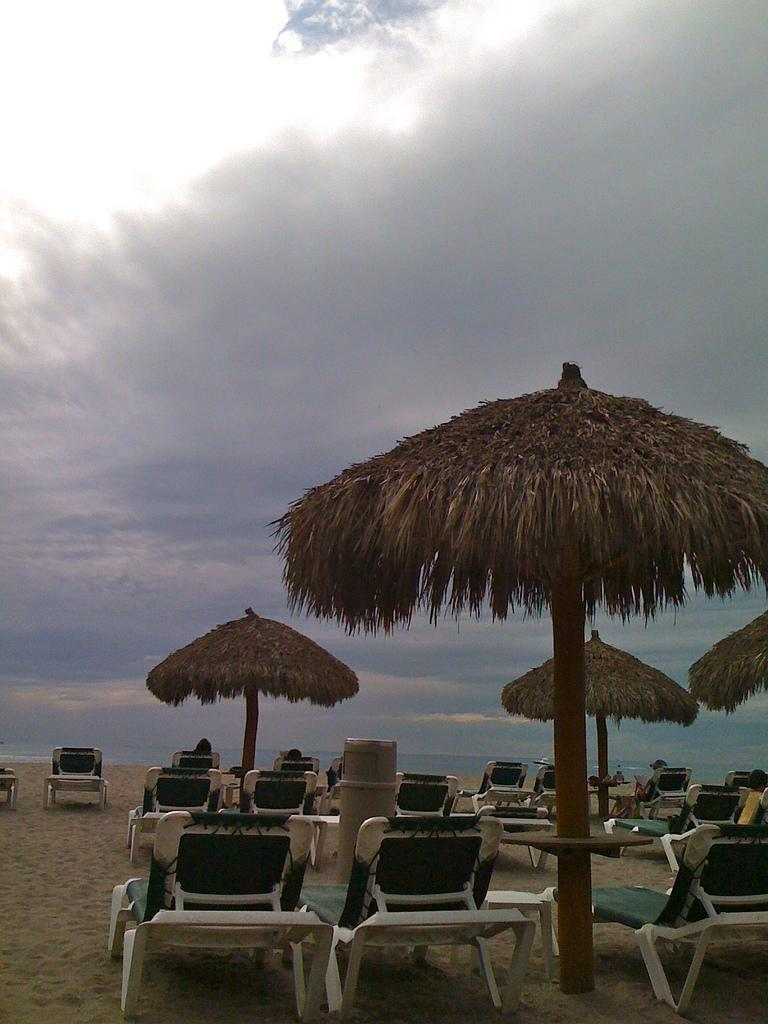Question: what are the weather conditions?
Choices:
A. Windy.
B. Sunny but cloudy.
C. Snowy.
D. Rainy.
Answer with the letter. Answer: B Question: where was this taken?
Choices:
A. Park.
B. Ocean.
C. Garage.
D. Street.
Answer with the letter. Answer: B Question: how many umbrellas do you see?
Choices:
A. One.
B. Two.
C. Three.
D. Four.
Answer with the letter. Answer: D Question: what are the chairs sitting on?
Choices:
A. Wood floor.
B. Sidewalk.
C. Sand.
D. Tile.
Answer with the letter. Answer: C Question: what are umbrellas made of and chairs?
Choices:
A. Umbrellas made out of plastic and chairs from metal.
B. Umbrellas made of grass shade tables and chairs from the sun on a beach.
C. Umbrellas made out of vinyl and chairs from brick.
D. Umbrellas made out of leather and chairs from clay.
Answer with the letter. Answer: B Question: what looms over the beach?
Choices:
A. Planes.
B. A bright, sunny sky.
C. Clouds.
D. A dark sky.
Answer with the letter. Answer: D Question: how is the sky?
Choices:
A. It is black because it's night.
B. There are no clouds and it is sunny.
C. There are clouds.
D. It is full of gray clouds.
Answer with the letter. Answer: C Question: why would someone go here?
Choices:
A. To relax.
B. To pray.
C. To have dinner.
D. To exercise.
Answer with the letter. Answer: A Question: how many umbrellas are there?
Choices:
A. Five.
B. Three.
C. Four.
D. Six.
Answer with the letter. Answer: C Question: what stands among the chairs?
Choices:
A. The children.
B. Trash can.
C. Cardboard boxes.
D. Shoes.
Answer with the letter. Answer: B Question: what is in the sand?
Choices:
A. Bugs.
B. Garbage.
C. Sea gulls.
D. Footprints.
Answer with the letter. Answer: D Question: what shape is the table?
Choices:
A. Square.
B. Rectangle.
C. Hexagonal.
D. Round.
Answer with the letter. Answer: D Question: where is the sun shining?
Choices:
A. Through the clouds.
B. Through the smog.
C. Through the smoke.
D. Through the rain.
Answer with the letter. Answer: A Question: how does the sky look?
Choices:
A. Bright and sunny.
B. Gray and rainy.
C. Dark and cloudy.
D. Pink and stormy.
Answer with the letter. Answer: C 